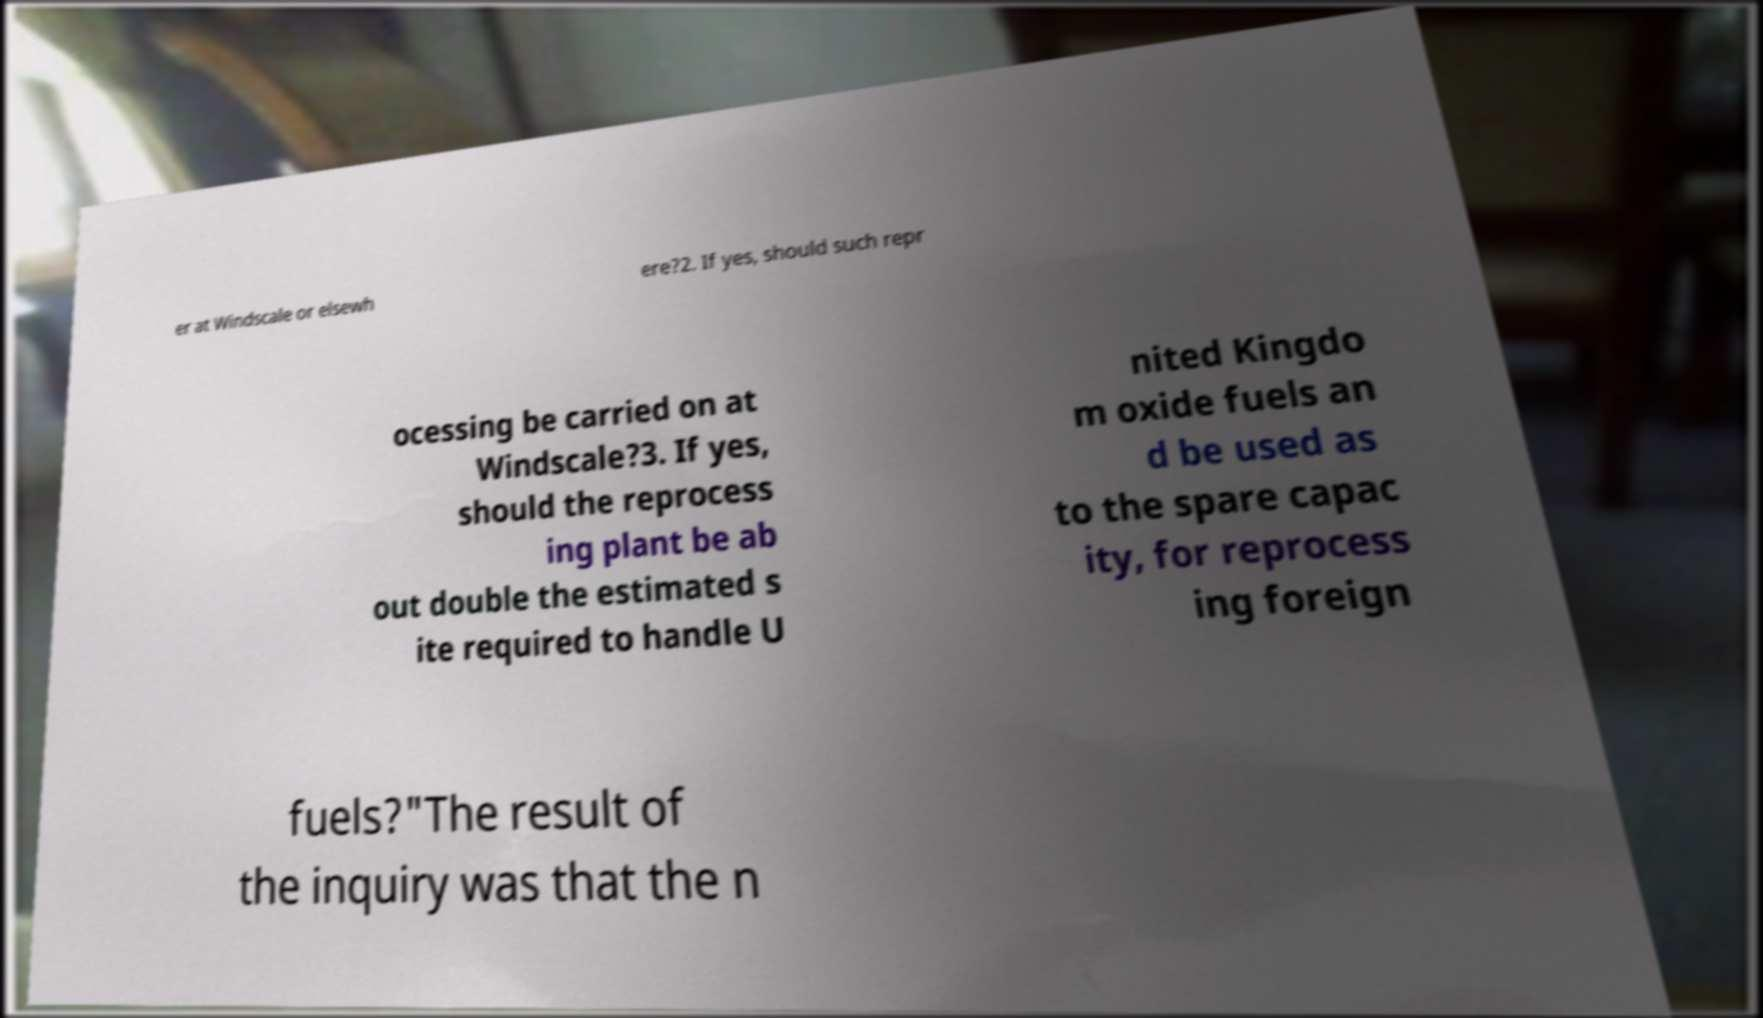I need the written content from this picture converted into text. Can you do that? er at Windscale or elsewh ere?2. If yes, should such repr ocessing be carried on at Windscale?3. If yes, should the reprocess ing plant be ab out double the estimated s ite required to handle U nited Kingdo m oxide fuels an d be used as to the spare capac ity, for reprocess ing foreign fuels?"The result of the inquiry was that the n 